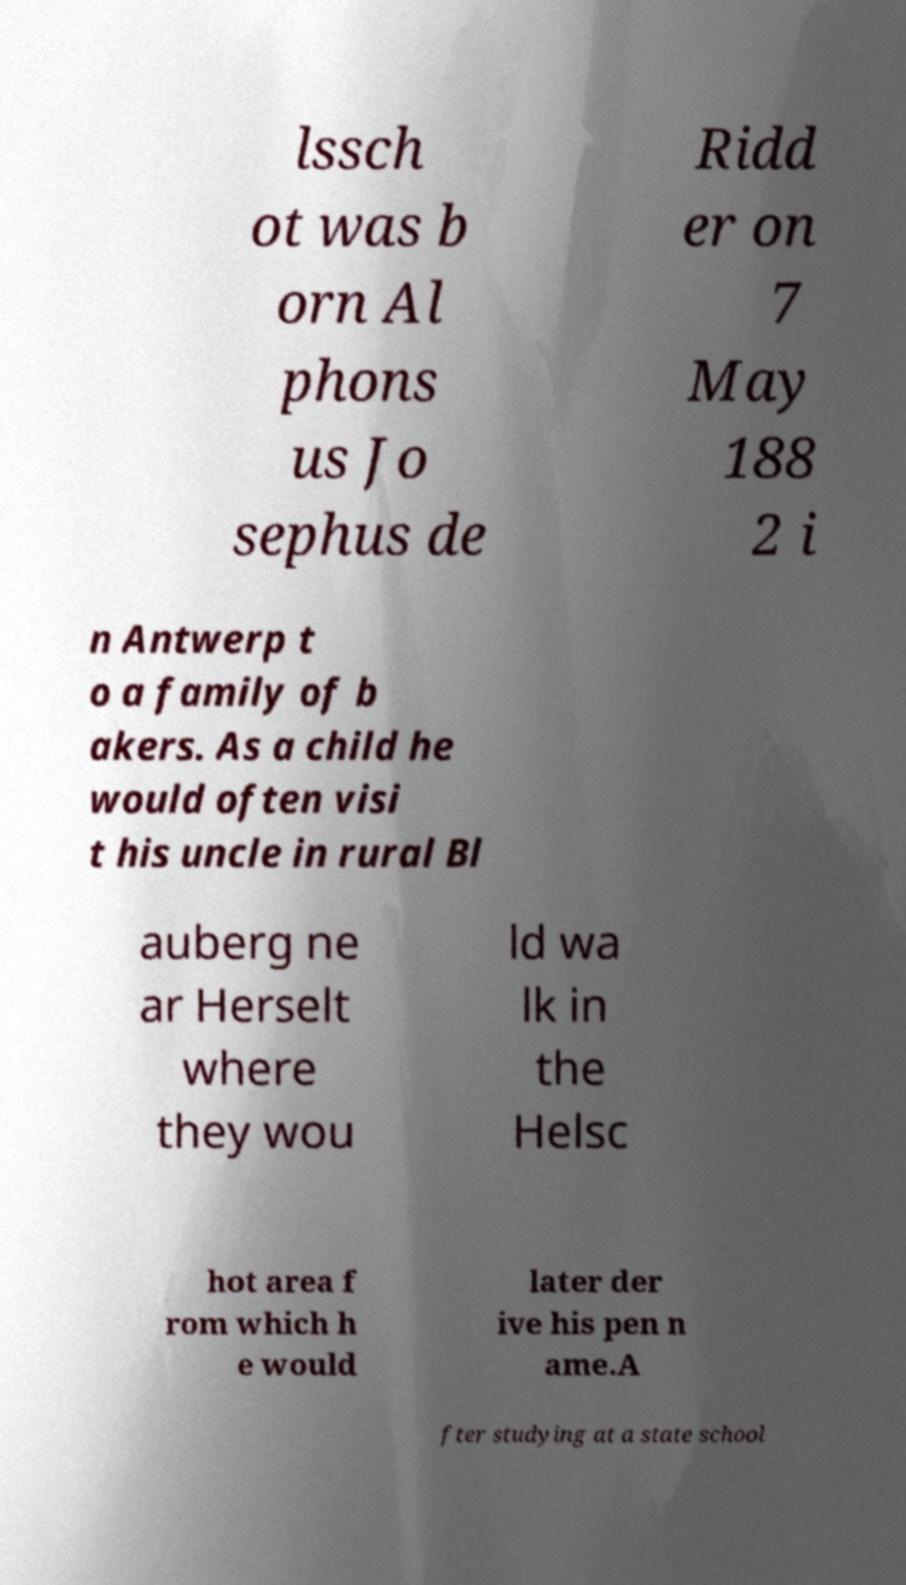Could you assist in decoding the text presented in this image and type it out clearly? lssch ot was b orn Al phons us Jo sephus de Ridd er on 7 May 188 2 i n Antwerp t o a family of b akers. As a child he would often visi t his uncle in rural Bl auberg ne ar Herselt where they wou ld wa lk in the Helsc hot area f rom which h e would later der ive his pen n ame.A fter studying at a state school 